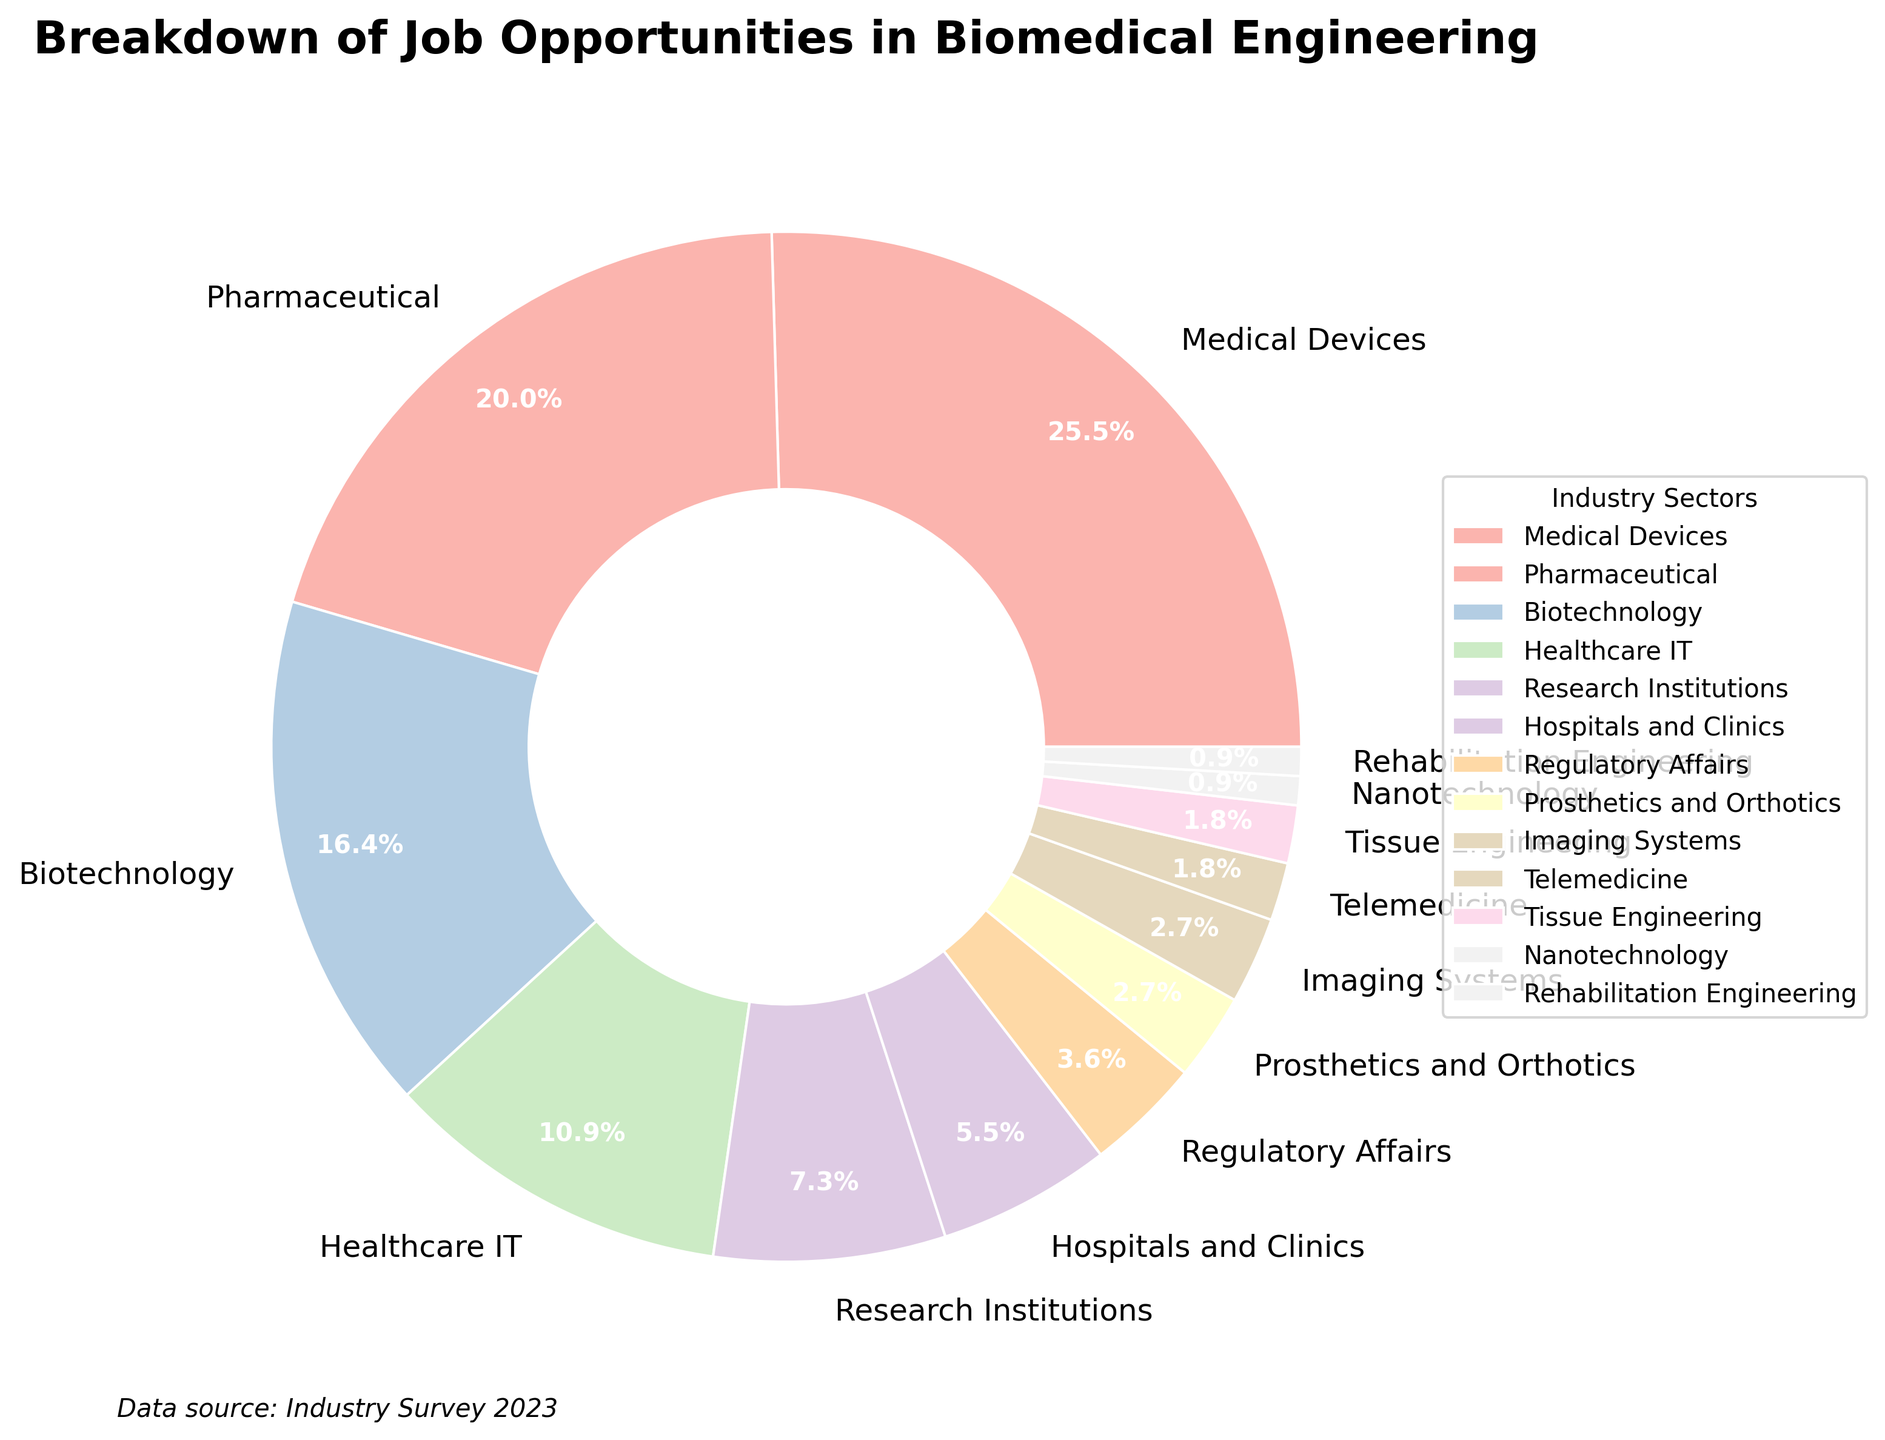How many industry sectors have less than 5% of the job opportunities? To determine how many industry sectors have less than 5% of the job opportunities, count the slices in the pie chart that have labels with percentages lower than 5%. These include Regulatory Affairs (4%), Prosthetics and Orthotics (3%), Imaging Systems (3%), Telemedicine (2%), Tissue Engineering (2%), Nanotechnology (1%), and Rehabilitation Engineering (1%). There are 7 sectors with less than 5%.
Answer: 7 What is the combined percentage of job opportunities in Biotechnology and Pharmaceuticals? Add the percentages of job opportunities in Biotechnology (18%) and Pharmaceuticals (22%). The combined percentage is 18% + 22% = 40%.
Answer: 40% Which industry sector has the largest portion of job opportunities? Look for the sector with the largest slice in the pie chart. The largest portion is Medical Devices, as it has the largest percentage label of 28%.
Answer: Medical Devices Is the percentage of job opportunities in Hospitals and Clinics greater than that in Regulatory Affairs? Compare the two sectors' percentages: Hospitals and Clinics (6%) and Regulatory Affairs (4%). Since 6% is greater than 4%, Hospitals and Clinics have a greater percentage.
Answer: Yes What is the range of percentages for the provided industry sectors? Determine the highest and lowest values in the pie chart percentages. The highest percentage is Medical Devices (28%) and the lowest is Nanotechnology and Rehabilitation Engineering, both at 1%. The range is 28% - 1% = 27%.
Answer: 27% How much larger is the percentage of job opportunities in Healthcare IT compared to Imaging Systems? Subtract the percentage of Imaging Systems (3%) from Healthcare IT (12%). The difference is 12% - 3% = 9%.
Answer: 9% Which industry sectors have equal percentages of job opportunities? Look for slices in the pie chart with the same percentage labels. Imaging Systems and Prosthetics and Orthotics both have 3%, and Telemedicine and Tissue Engineering both have 2%.
Answer: Imaging Systems and Prosthetics and Orthotics; Telemedicine and Tissue Engineering What is the total percentage of the smallest four industry sectors? Add the percentages of the smallest four sectors: Nanotechnology (1%), Rehabilitation Engineering (1%), Tissue Engineering (2%), and Telemedicine (2%). The total is 1% + 1% + 2% + 2% = 6%.
Answer: 6% What percentage of job opportunities are in sectors related to patient care (Hospitals and Clinics, Telemedicine, Rehabilitation Engineering)? Add the percentages of Hospitals and Clinics (6%), Telemedicine (2%), and Rehabilitation Engineering (1%). The total is 6% + 2% + 1% = 9%.
Answer: 9% 